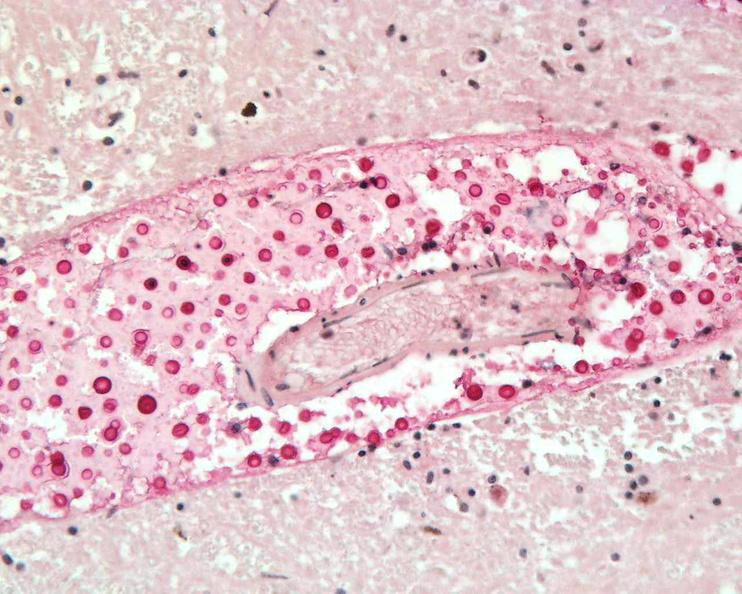does peritoneum show brain, cryptococcal meningitis?
Answer the question using a single word or phrase. No 